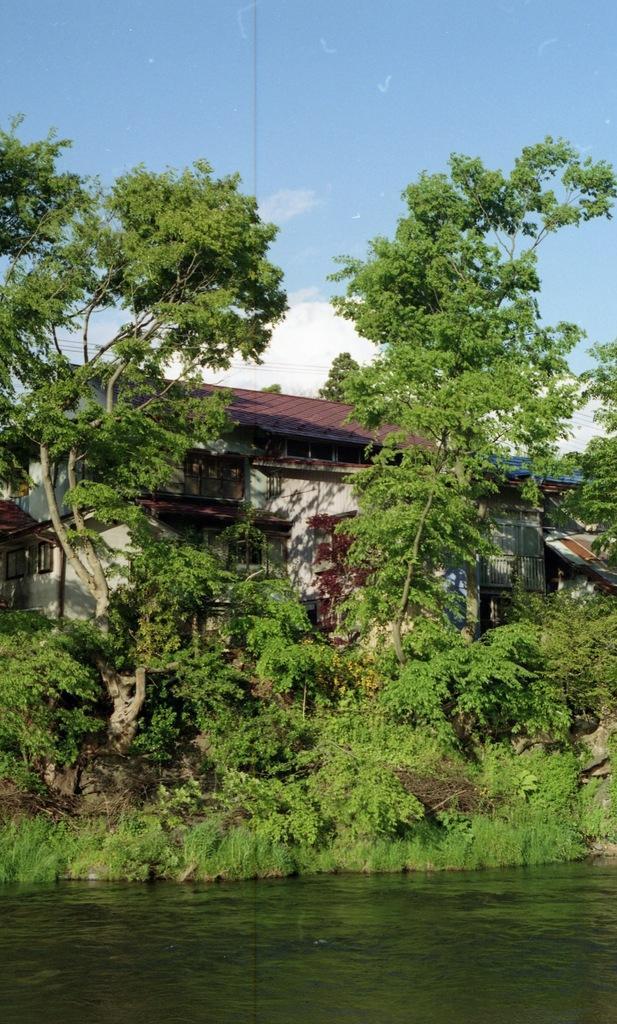In one or two sentences, can you explain what this image depicts? In this image we can see water, plants, trees, and a house. In the background there is sky with clouds. 